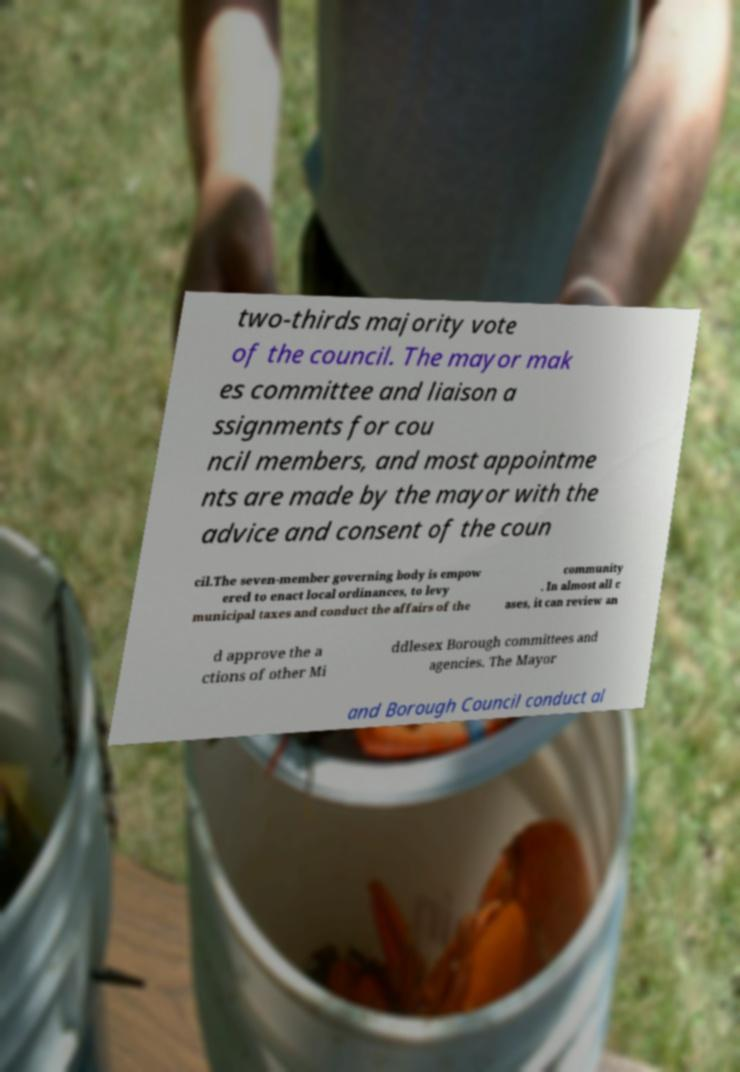Please read and relay the text visible in this image. What does it say? two-thirds majority vote of the council. The mayor mak es committee and liaison a ssignments for cou ncil members, and most appointme nts are made by the mayor with the advice and consent of the coun cil.The seven-member governing body is empow ered to enact local ordinances, to levy municipal taxes and conduct the affairs of the community . In almost all c ases, it can review an d approve the a ctions of other Mi ddlesex Borough committees and agencies. The Mayor and Borough Council conduct al 